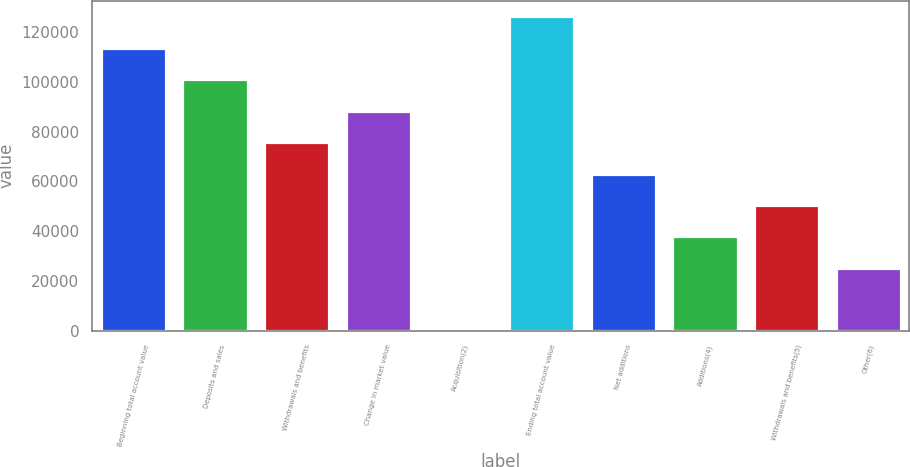<chart> <loc_0><loc_0><loc_500><loc_500><bar_chart><fcel>Beginning total account value<fcel>Deposits and sales<fcel>Withdrawals and benefits<fcel>Change in market value<fcel>Acquisition(2)<fcel>Ending total account value<fcel>Net additions<fcel>Additions(4)<fcel>Withdrawals and benefits(5)<fcel>Other(6)<nl><fcel>113711<fcel>101076<fcel>75807.8<fcel>88442.1<fcel>1.97<fcel>126345<fcel>63173.5<fcel>37904.9<fcel>50539.2<fcel>25270.6<nl></chart> 